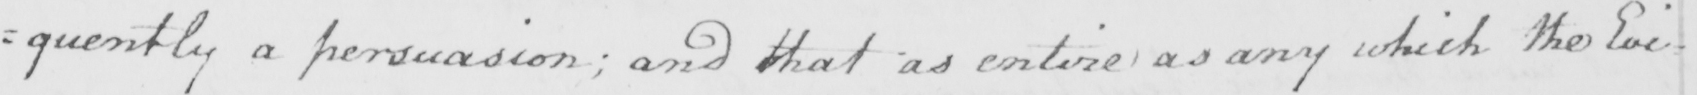What does this handwritten line say? =quently a persuasion ; and that as entire as any which the Evi= 